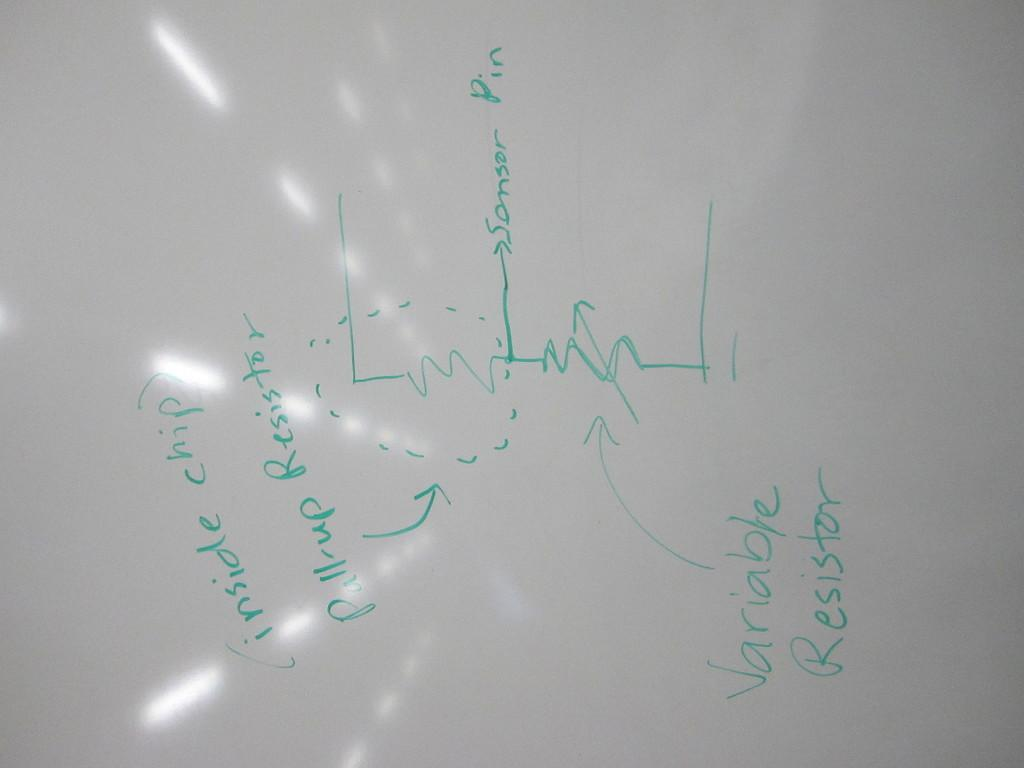<image>
Relay a brief, clear account of the picture shown. A piece of paper has words relating to physics, such as variable resistor and pull-up resistor 